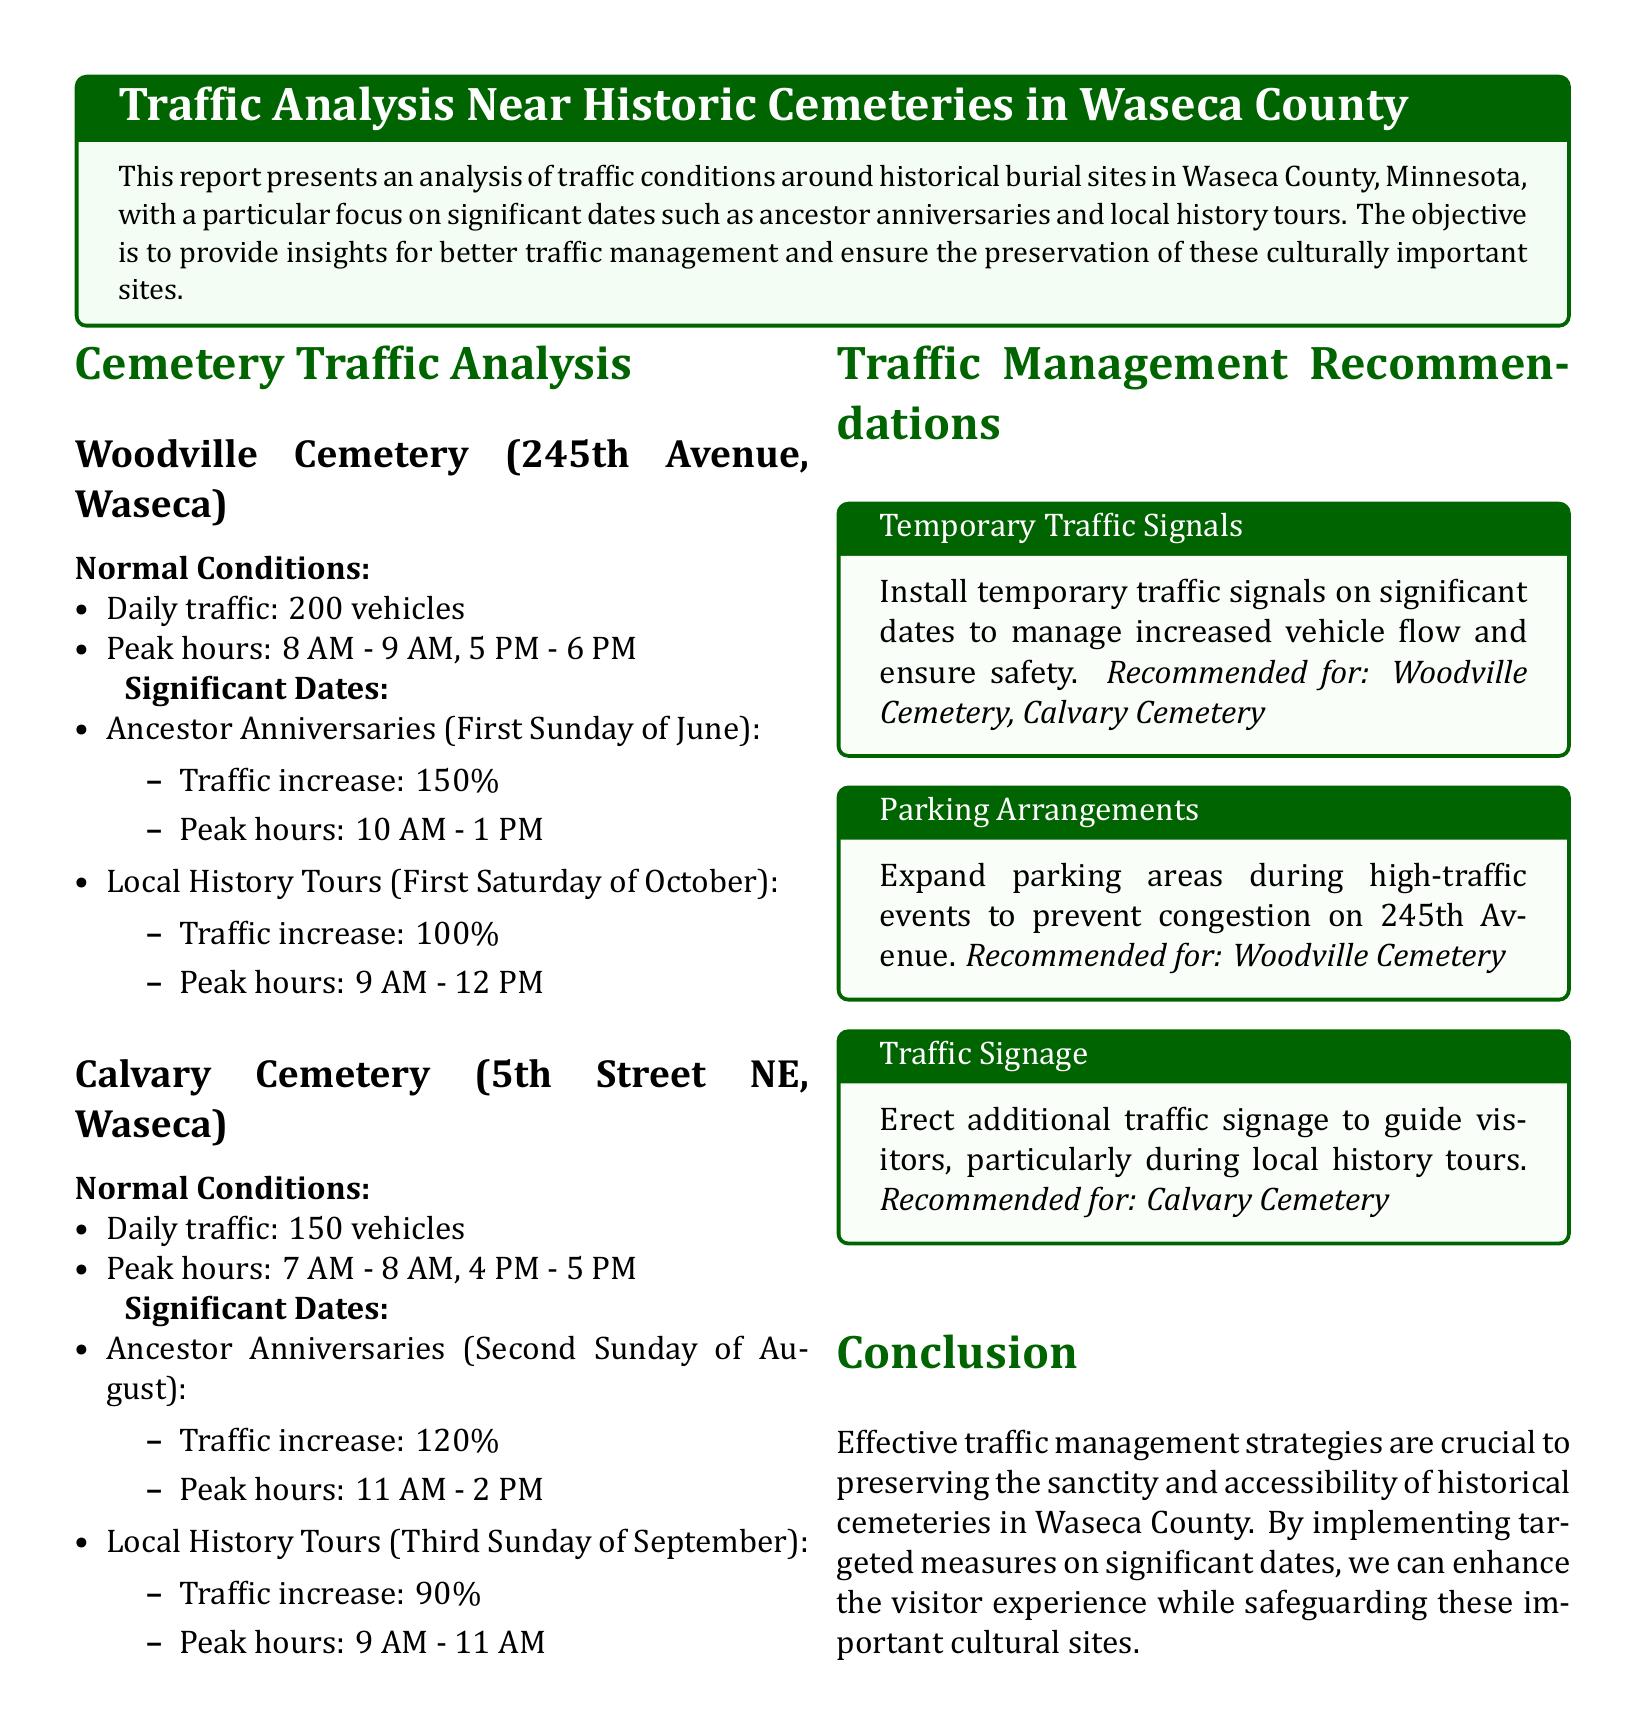What is the daily traffic at Woodville Cemetery? The daily traffic at Woodville Cemetery is listed in the report.
Answer: 200 vehicles What is the traffic increase during Ancestor Anniversaries at Calvary Cemetery? The report specifies the traffic increase during significant dates, including Ancestor Anniversaries at Calvary Cemetery.
Answer: 120% What are the peak hours for traffic increase during local history tours at Woodville Cemetery? The document provides peak hours for various events, including local history tours at Woodville Cemetery.
Answer: 10 AM - 1 PM What is a traffic management recommendation for Calvary Cemetery? The report suggests specific traffic management strategies tailored to each cemetery.
Answer: Erect additional traffic signage On which date is the Ancestor Anniversaries event for Woodville Cemetery? The report details significant dates for events at the cemeteries, including Ancestor Anniversaries at Woodville Cemetery.
Answer: First Sunday of June How much is the traffic increase for local history tours at Calvary Cemetery? The document quantifies the expected traffic increase during local history tours at Calvary Cemetery.
Answer: 90% What is a suggested parking arrangement during high-traffic events at Woodville Cemetery? Recommendations for managing traffic often include suggestions for parking arrangements during events.
Answer: Expand parking areas What are the normal peak hours for Calvary Cemetery? The report lists the normal peak hours for traffic at Calvary Cemetery.
Answer: 7 AM - 8 AM, 4 PM - 5 PM 